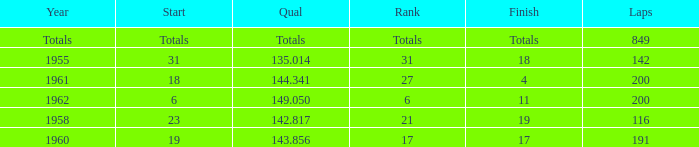What year has a finish of 19? 1958.0. 